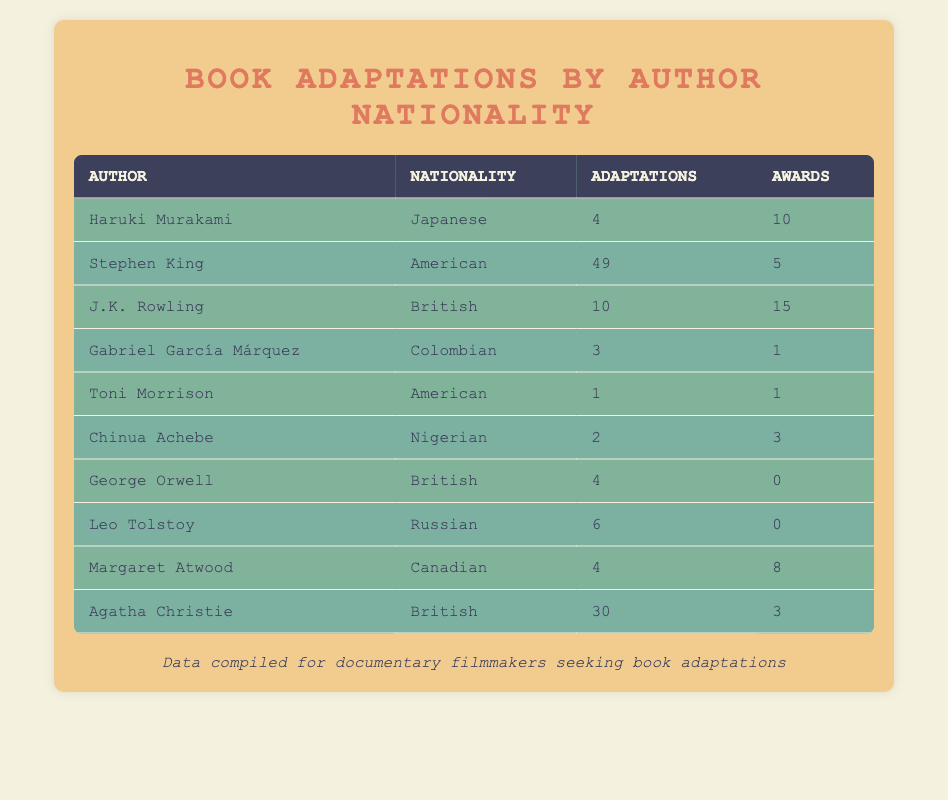What is the total number of adaptations by American authors? The American authors in the table are Stephen King (49 adaptations) and Toni Morrison (1 adaptation). Adding their adaptations together gives us 49 + 1 = 50 adaptations total.
Answer: 50 Which author received the most awards? The author with the most awards in the table is J.K. Rowling, who received 15 awards. This is the highest number compared to other authors listed.
Answer: J.K. Rowling Is it true that Gabriel García Márquez has more adaptations than Chinua Achebe? Gabriel García Márquez has 3 adaptations, while Chinua Achebe has 2 adaptations. Since 3 is greater than 2, the statement is true.
Answer: True What is the average number of adaptations for British authors? The British authors in the table are J.K. Rowling (10 adaptations), George Orwell (4 adaptations), and Agatha Christie (30 adaptations). Adding them gives 10 + 4 + 30 = 44 adaptations in total. There are 3 British authors, so the average is 44/3 = 14.67 adaptations.
Answer: 14.67 How many authors received no awards? Looking at the table, George Orwell (0 awards) and Leo Tolstoy (0 awards) are the only authors with no awards. Thus, there are a total of 2 authors who received no awards.
Answer: 2 What is the difference in the number of adaptations between the most and least adapted authors? The most adapted author is Stephen King with 49 adaptations, and the least adapted author is Toni Morrison with 1 adaptation. The difference is 49 - 1 = 48 adaptations.
Answer: 48 What nationality has the highest total number of adaptations? The total adaptations by nationality can be calculated: American (50), Japanese (4), British (44), Colombian (3), Nigerian (2), Russian (6), Canadian (4). American authors have the highest total with 50 adaptations.
Answer: American How many authors have more than 5 adaptations? The authors with more than 5 adaptations are Stephen King (49), J.K. Rowling (10), Agatha Christie (30), and Leo Tolstoy (6). Therefore, there are a total of 4 authors with more than 5 adaptations.
Answer: 4 